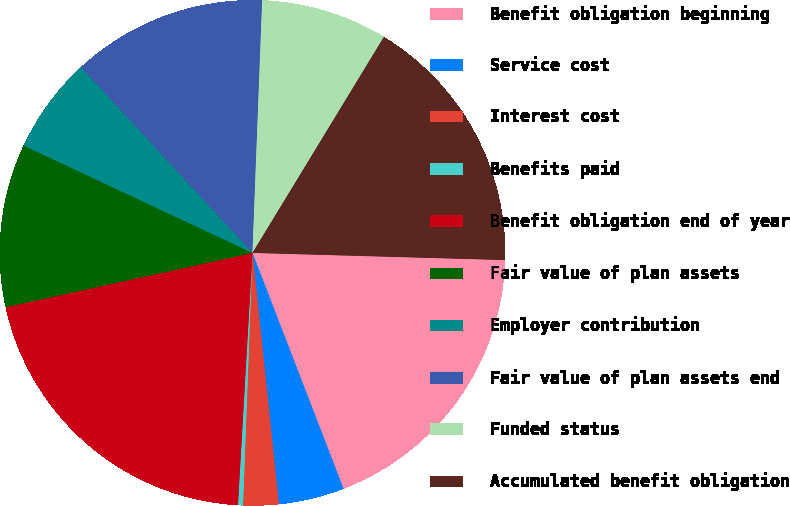<chart> <loc_0><loc_0><loc_500><loc_500><pie_chart><fcel>Benefit obligation beginning<fcel>Service cost<fcel>Interest cost<fcel>Benefits paid<fcel>Benefit obligation end of year<fcel>Fair value of plan assets<fcel>Employer contribution<fcel>Fair value of plan assets end<fcel>Funded status<fcel>Accumulated benefit obligation<nl><fcel>18.69%<fcel>4.2%<fcel>2.26%<fcel>0.32%<fcel>20.64%<fcel>10.43%<fcel>6.15%<fcel>12.48%<fcel>8.09%<fcel>16.75%<nl></chart> 